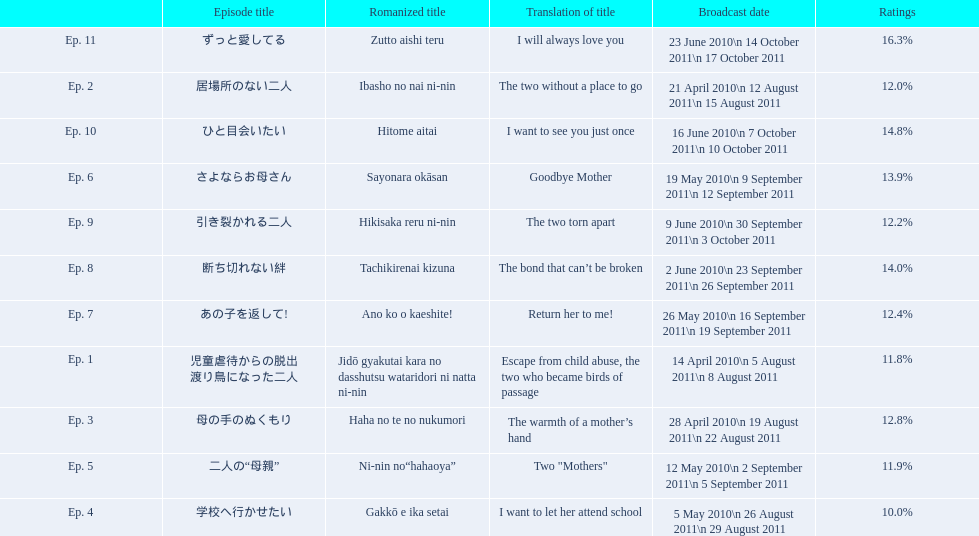How many total episodes are there? Ep. 1, Ep. 2, Ep. 3, Ep. 4, Ep. 5, Ep. 6, Ep. 7, Ep. 8, Ep. 9, Ep. 10, Ep. 11. Of those episodes, which one has the title of the bond that can't be broken? Ep. 8. What was the ratings percentage for that episode? 14.0%. 